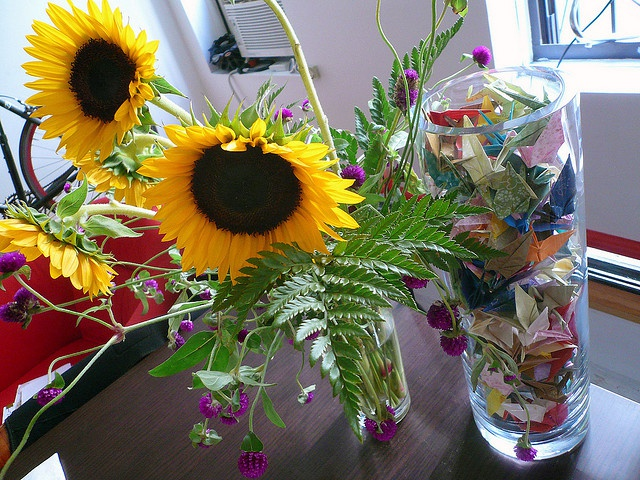Describe the objects in this image and their specific colors. I can see potted plant in lightblue, black, darkgreen, and orange tones, vase in lightblue, gray, black, darkgray, and white tones, dining table in lightblue, black, gray, and purple tones, couch in lightblue, maroon, orange, and olive tones, and vase in lightblue, darkgreen, gray, and darkgray tones in this image. 